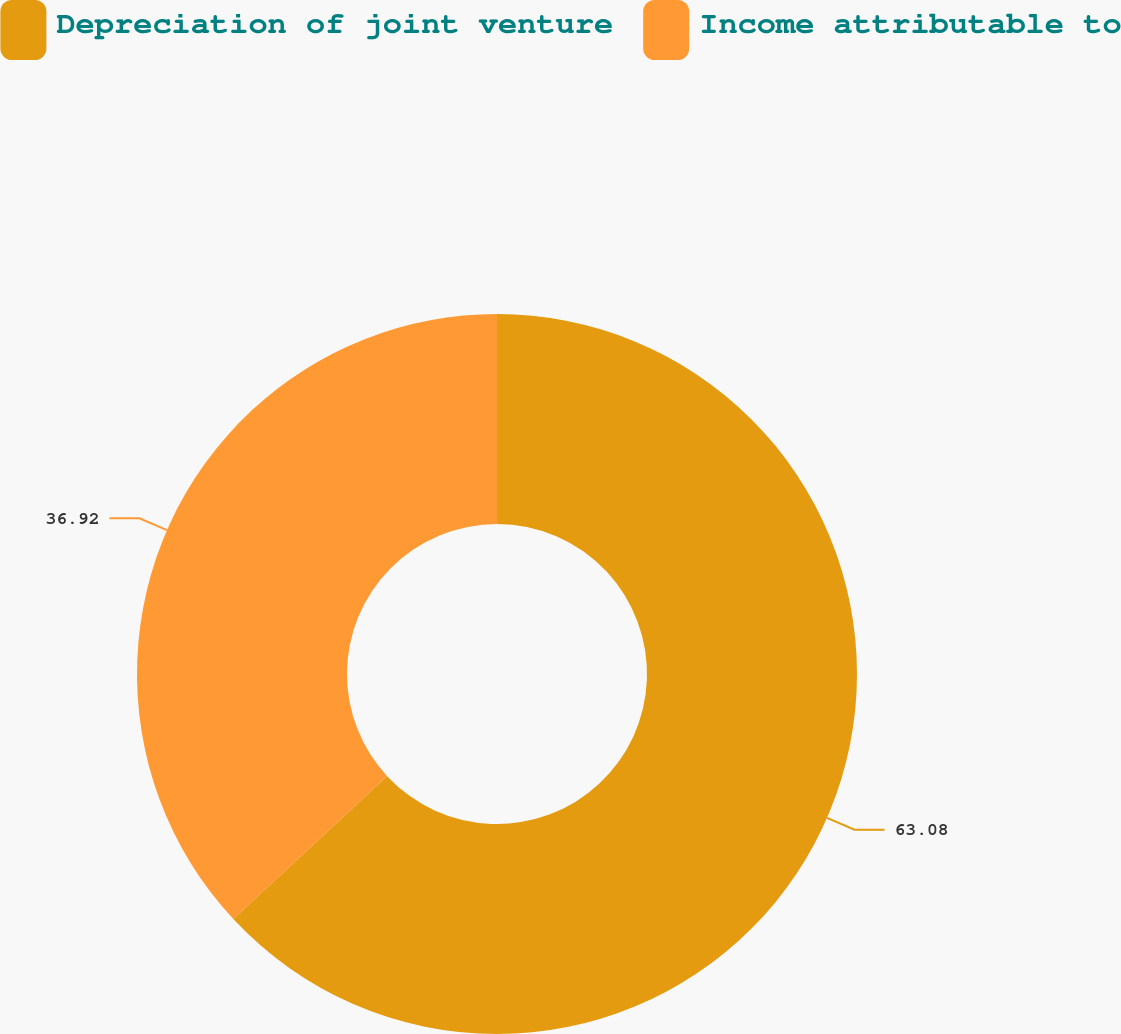Convert chart to OTSL. <chart><loc_0><loc_0><loc_500><loc_500><pie_chart><fcel>Depreciation of joint venture<fcel>Income attributable to<nl><fcel>63.08%<fcel>36.92%<nl></chart> 